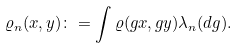<formula> <loc_0><loc_0><loc_500><loc_500>\varrho _ { n } ( x , y ) \colon = \int \varrho ( g x , g y ) \lambda _ { n } ( d g ) .</formula> 